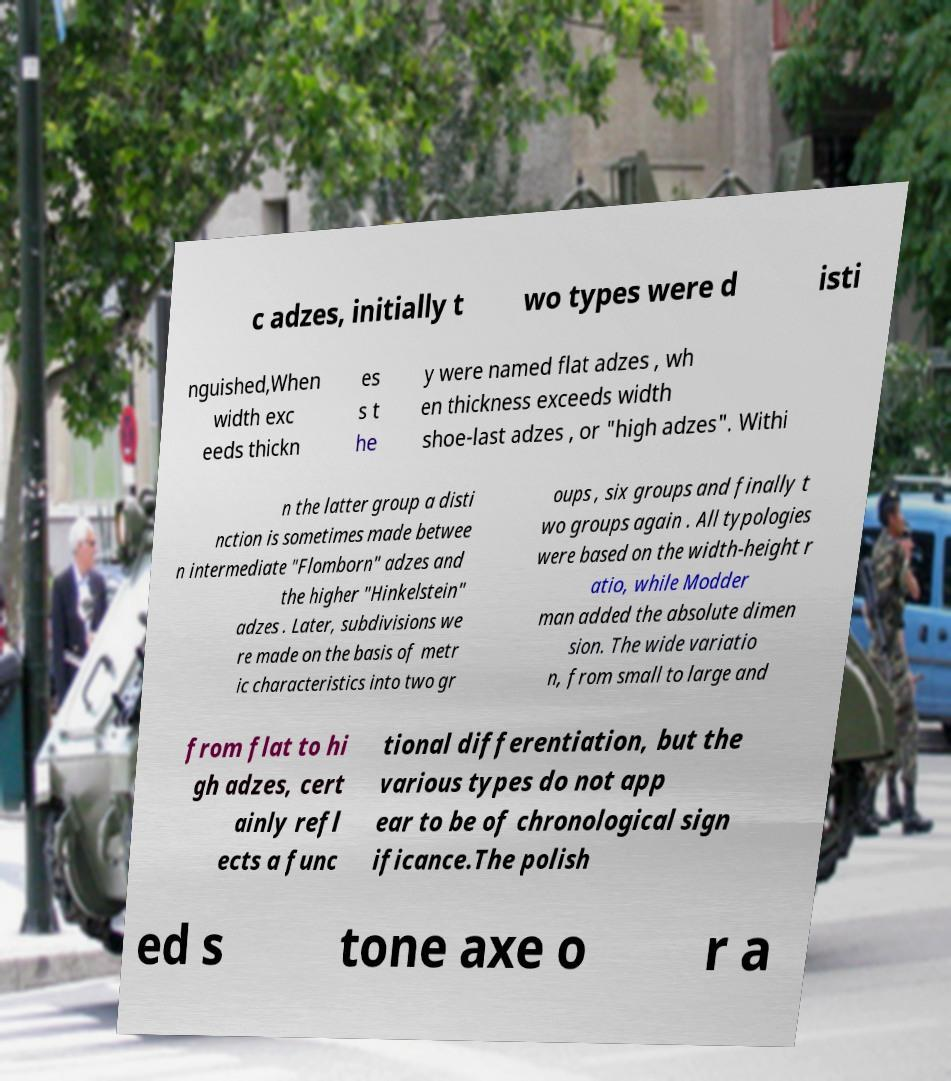What messages or text are displayed in this image? I need them in a readable, typed format. c adzes, initially t wo types were d isti nguished,When width exc eeds thickn es s t he y were named flat adzes , wh en thickness exceeds width shoe-last adzes , or "high adzes". Withi n the latter group a disti nction is sometimes made betwee n intermediate "Flomborn" adzes and the higher "Hinkelstein" adzes . Later, subdivisions we re made on the basis of metr ic characteristics into two gr oups , six groups and finally t wo groups again . All typologies were based on the width-height r atio, while Modder man added the absolute dimen sion. The wide variatio n, from small to large and from flat to hi gh adzes, cert ainly refl ects a func tional differentiation, but the various types do not app ear to be of chronological sign ificance.The polish ed s tone axe o r a 